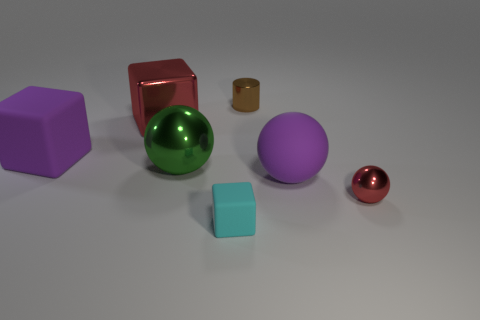Subtract all purple cylinders. Subtract all purple cubes. How many cylinders are left? 1 Add 1 tiny cyan cubes. How many objects exist? 8 Subtract all blocks. How many objects are left? 4 Add 1 blue cylinders. How many blue cylinders exist? 1 Subtract 0 green cylinders. How many objects are left? 7 Subtract all big shiny objects. Subtract all green objects. How many objects are left? 4 Add 3 rubber objects. How many rubber objects are left? 6 